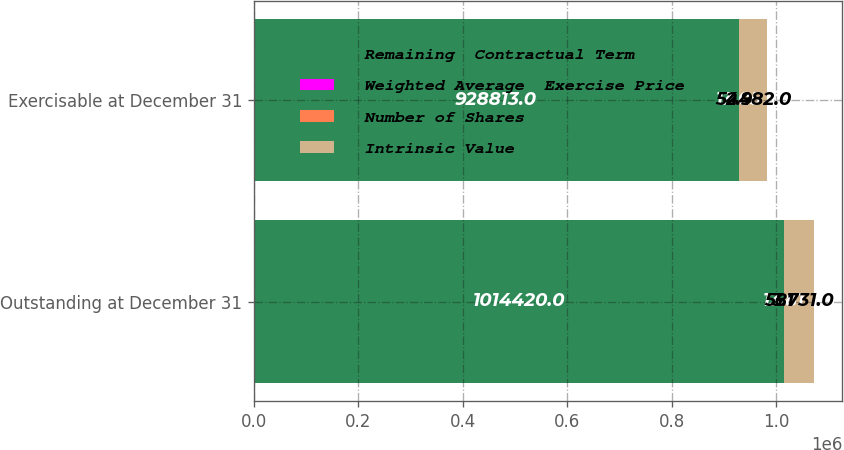Convert chart to OTSL. <chart><loc_0><loc_0><loc_500><loc_500><stacked_bar_chart><ecel><fcel>Outstanding at December 31<fcel>Exercisable at December 31<nl><fcel>Remaining  Contractual Term<fcel>1.01442e+06<fcel>928813<nl><fcel>Weighted Average  Exercise Price<fcel>13.81<fcel>13.05<nl><fcel>Number of Shares<fcel>3.1<fcel>2.9<nl><fcel>Intrinsic Value<fcel>58731<fcel>54482<nl></chart> 